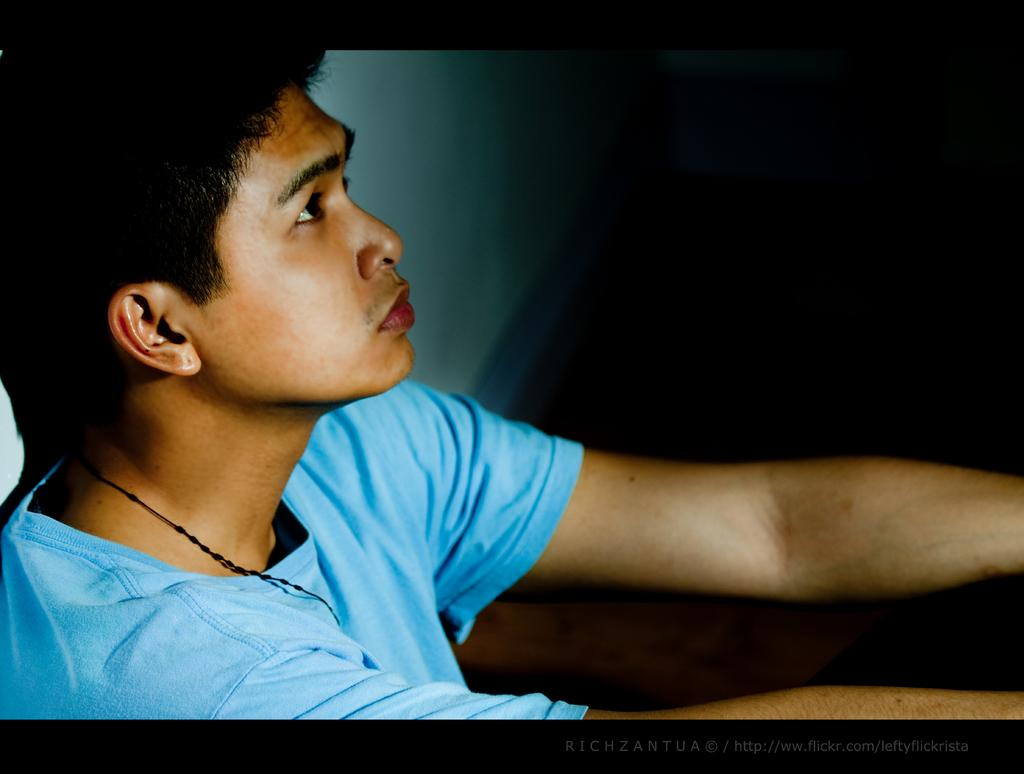Who is present in the image? There is a man in the image. What is the man wearing? The man is wearing a blue T-shirt. What can be seen in the background of the image? There is a wall in the background of the image. How would you describe the lighting on the right side of the image? The right side background of the image is dark. How many bits of information can be found in the man's statement in the image? There is no man making a statement in the image, so it is not possible to determine the number of bits of information. 